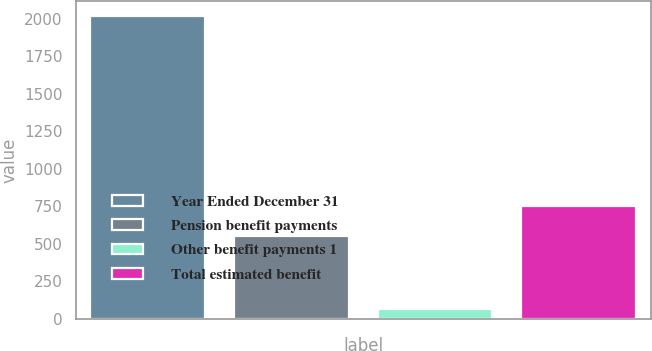Convert chart. <chart><loc_0><loc_0><loc_500><loc_500><bar_chart><fcel>Year Ended December 31<fcel>Pension benefit payments<fcel>Other benefit payments 1<fcel>Total estimated benefit<nl><fcel>2017<fcel>554<fcel>65<fcel>749.2<nl></chart> 